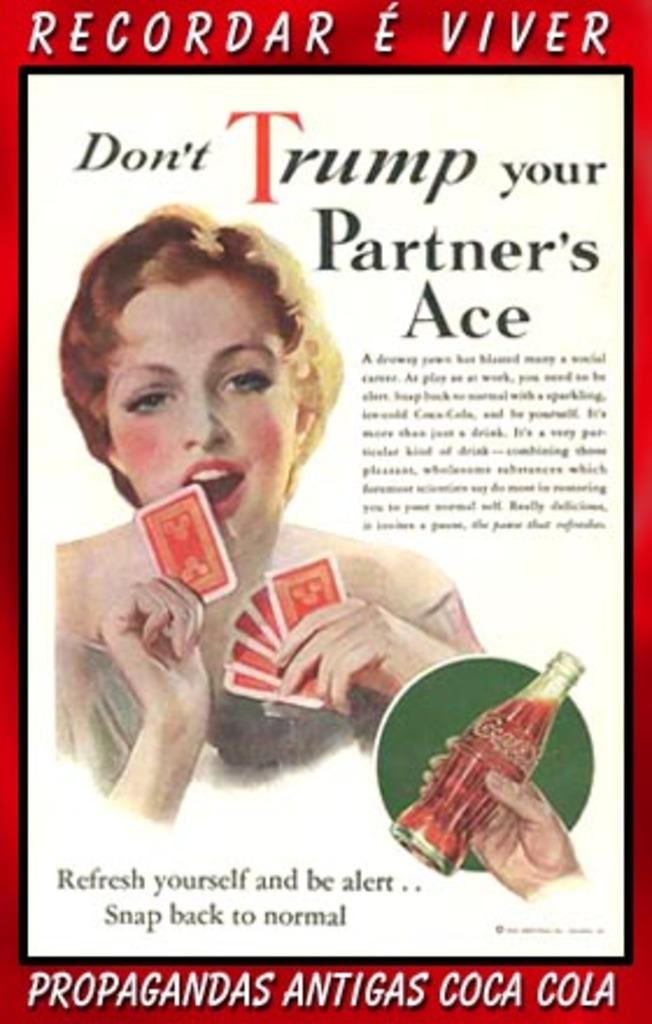What is the main subject of the poster in the image? The poster contains an image of a woman holding cards. What else can be seen in the woman's hand on the poster? The woman is holding a bottle in her hand. What additional information is present on the poster? The poster contains some information. Can you see any ice on the poster in the image? There is no ice present on the poster in the image. Is the woman wearing a crown in the image? There is no crown visible on the woman in the image. 